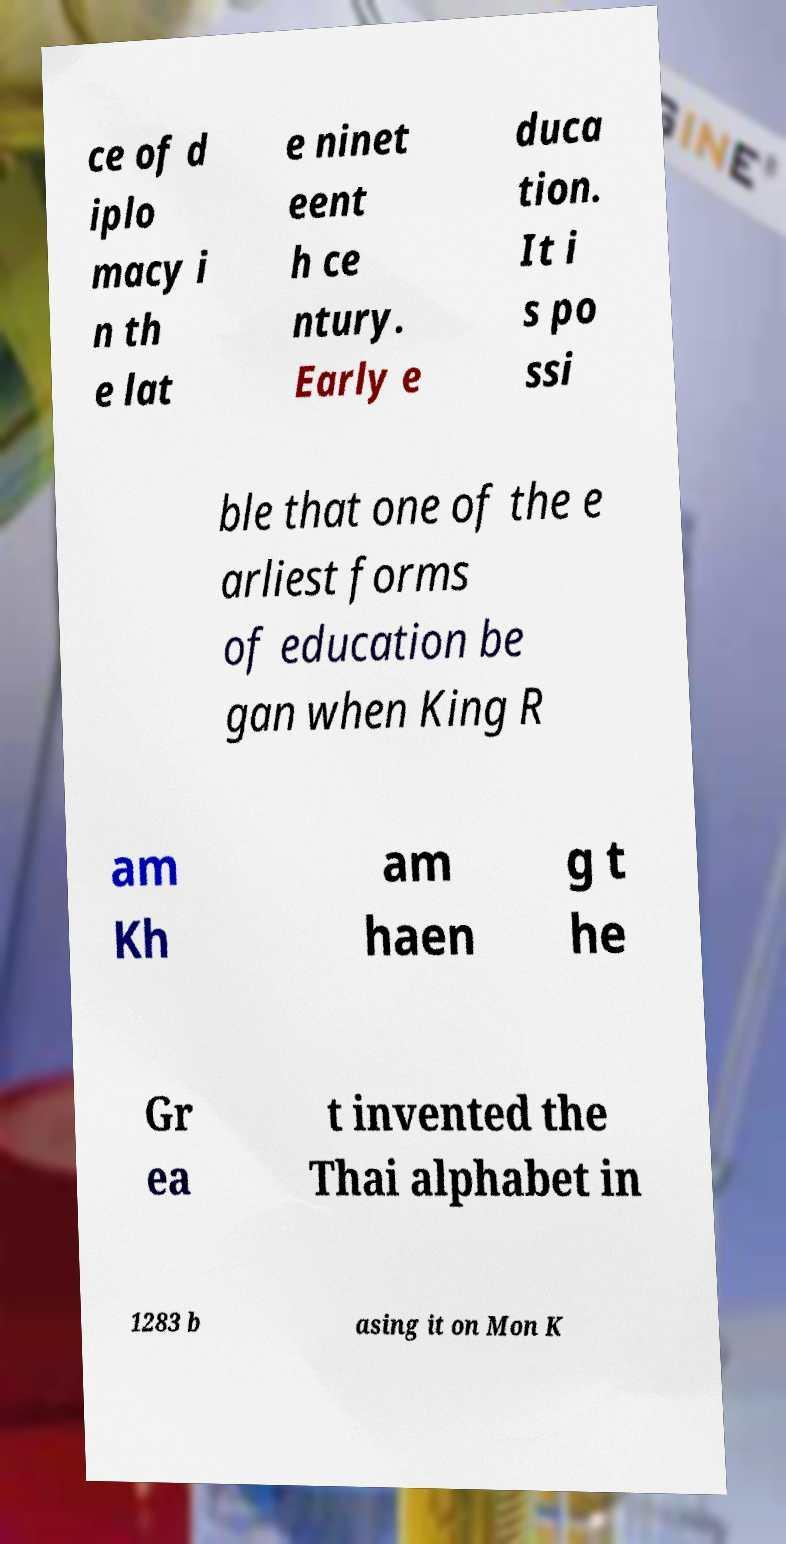I need the written content from this picture converted into text. Can you do that? ce of d iplo macy i n th e lat e ninet eent h ce ntury. Early e duca tion. It i s po ssi ble that one of the e arliest forms of education be gan when King R am Kh am haen g t he Gr ea t invented the Thai alphabet in 1283 b asing it on Mon K 